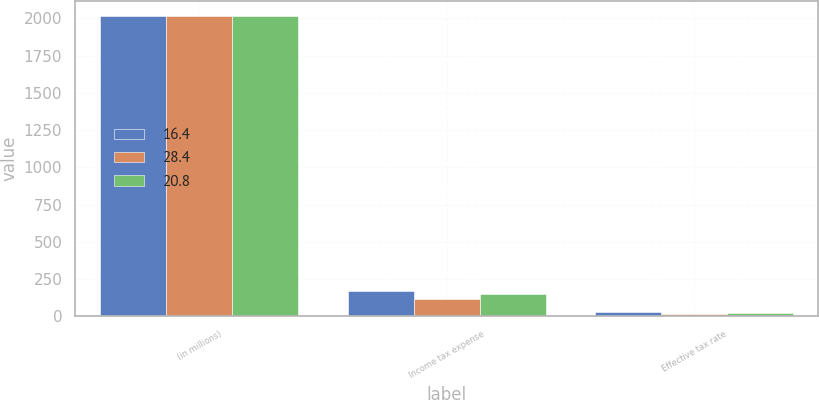Convert chart. <chart><loc_0><loc_0><loc_500><loc_500><stacked_bar_chart><ecel><fcel>(in millions)<fcel>Income tax expense<fcel>Effective tax rate<nl><fcel>16.4<fcel>2019<fcel>171.5<fcel>28.4<nl><fcel>28.4<fcel>2018<fcel>118.8<fcel>16.4<nl><fcel>20.8<fcel>2017<fcel>148.9<fcel>20.8<nl></chart> 